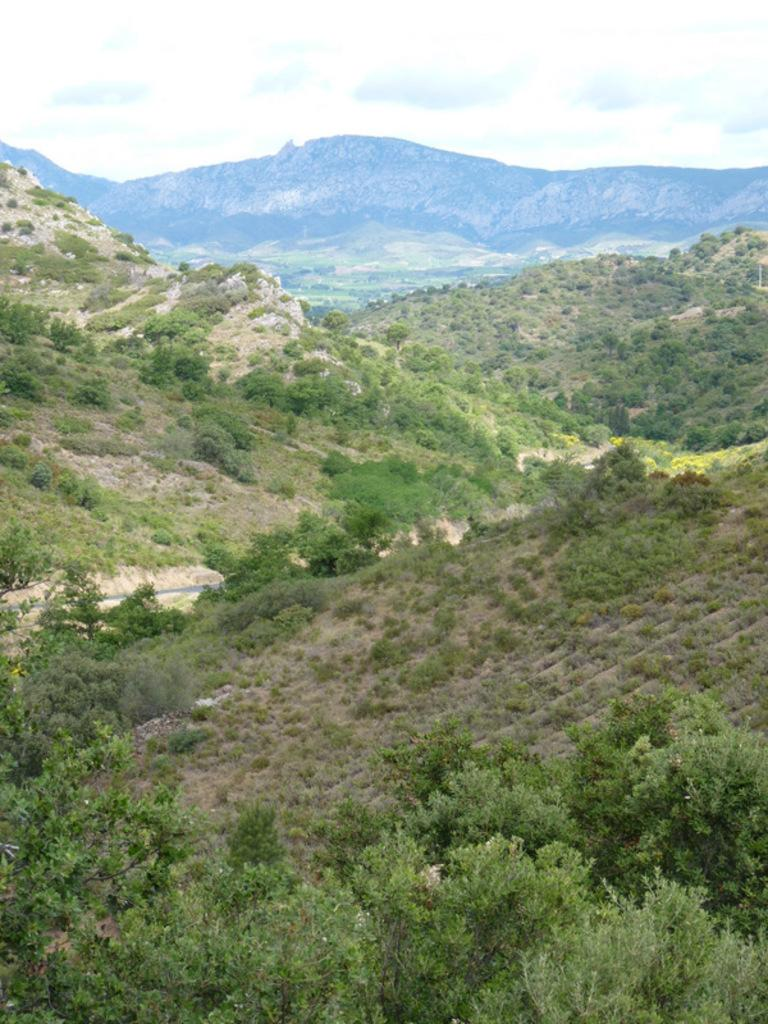What type of natural landscape is depicted in the image? The image features a group of trees and mountains. What can be seen in the background of the image? The sky is visible in the background of the image. What news headline is displayed on the record in the image? There is no record or news headline present in the image. 